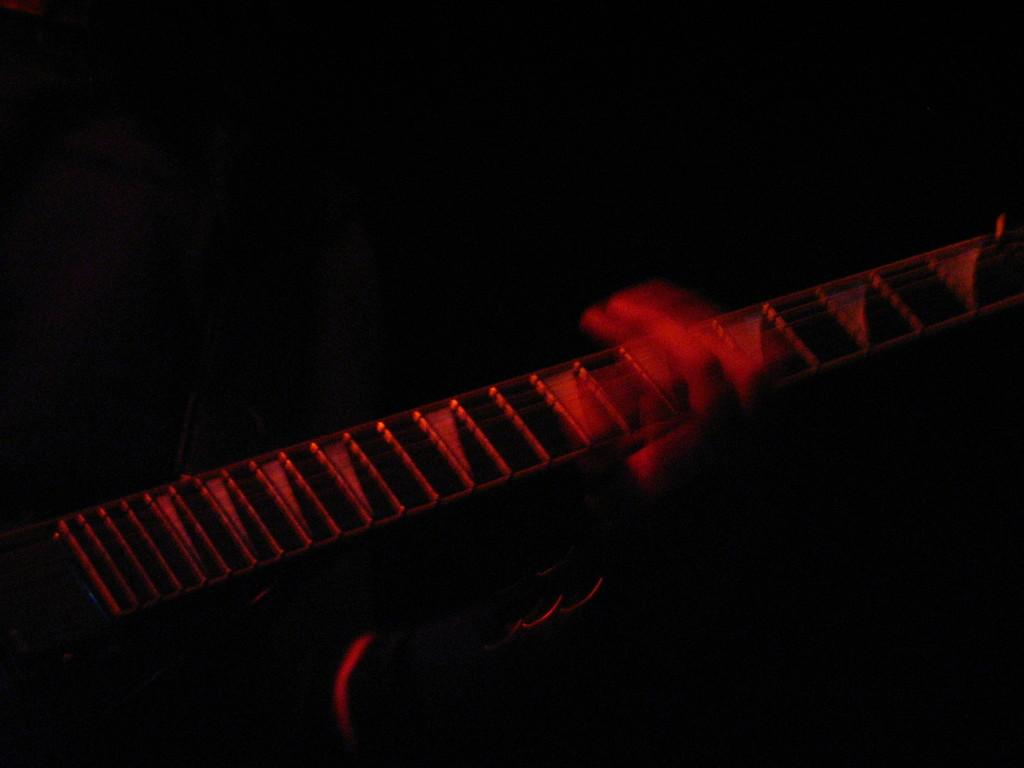What part of a person can be seen in the image? There is a person's hand in the image. What is the person holding in the image? The person is holding a guitar. What is the color of the background in the image? The background of the image is dark. How many trucks can be seen in the image? There are no trucks present in the image. What type of acoustics is the person using to play the guitar in the image? The image does not provide information about the acoustics used to play the guitar. 